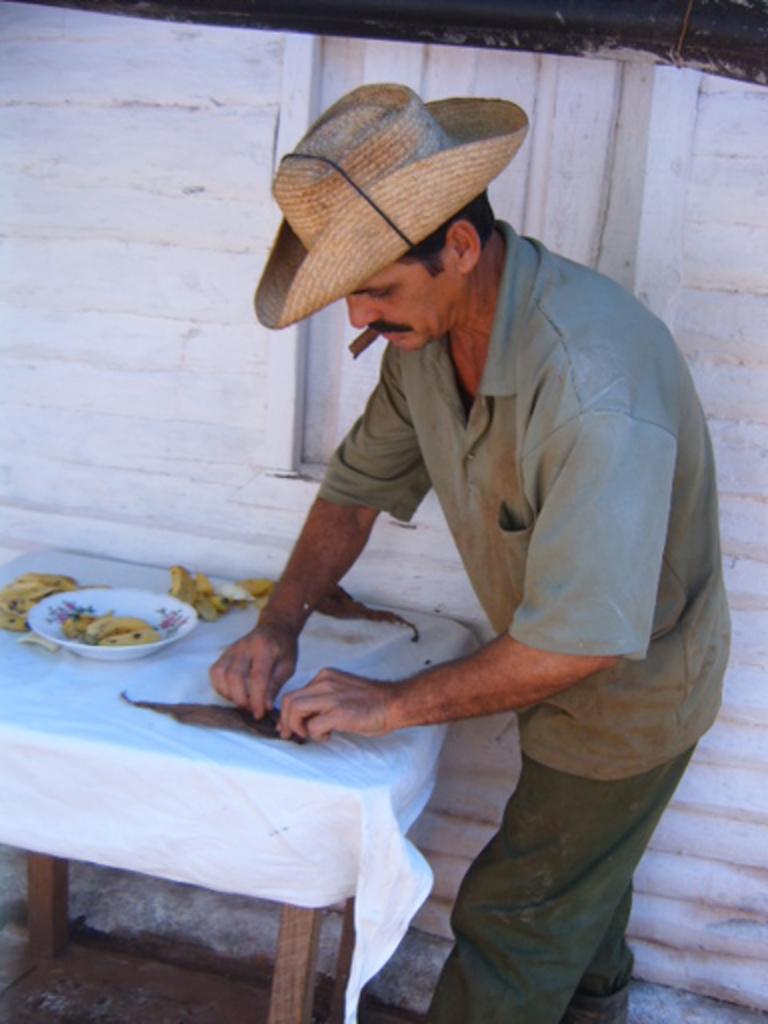Could you give a brief overview of what you see in this image? This is the man standing. He wore a hat on his hand. This is a small table covered with white cloth. This is a plate with bananas which is placed on the table. At background I can see a wall with a small window. 